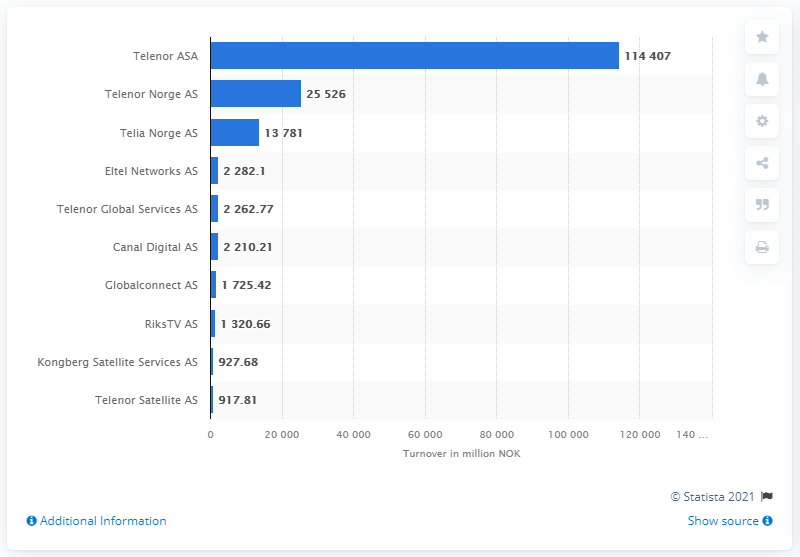Highlight a few significant elements in this photo. Telenor ASA's turnover in Norwegian kroner was 114,407... Telenor ASA is the leading telecom company in Norway, according to a recent ranking. The revenues of Telenor Norge AS and Telia Norge AS in 2022 were 114,407. 